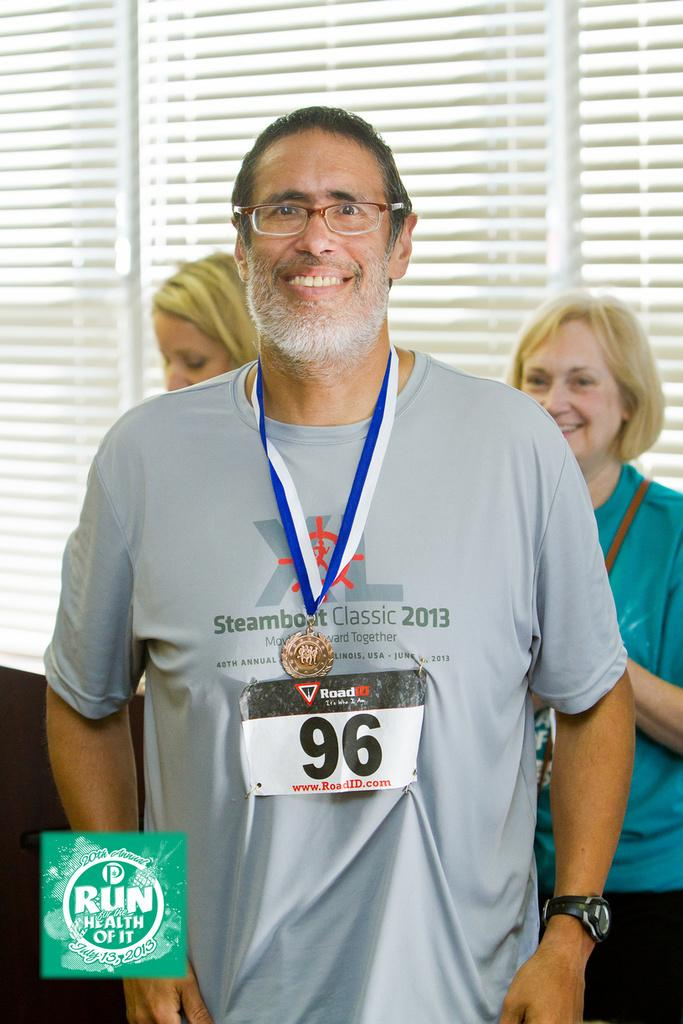Provide a one-sentence caption for the provided image. A man wearing his Steamboat Classic shirt is proudly displaying his finishing medal. 